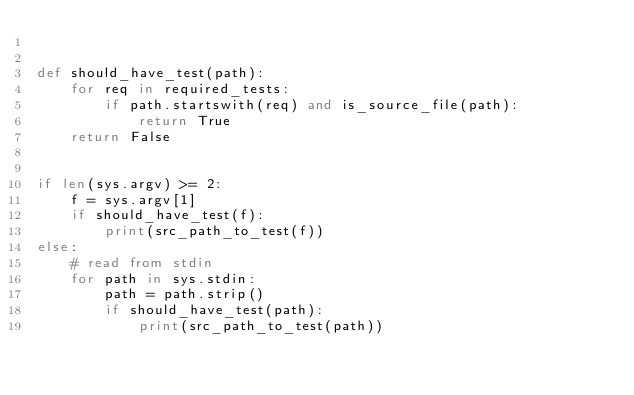<code> <loc_0><loc_0><loc_500><loc_500><_Python_>

def should_have_test(path):
    for req in required_tests:
        if path.startswith(req) and is_source_file(path):
            return True
    return False


if len(sys.argv) >= 2:
    f = sys.argv[1]
    if should_have_test(f):
        print(src_path_to_test(f))
else:
    # read from stdin
    for path in sys.stdin:
        path = path.strip()
        if should_have_test(path):
            print(src_path_to_test(path))
</code> 